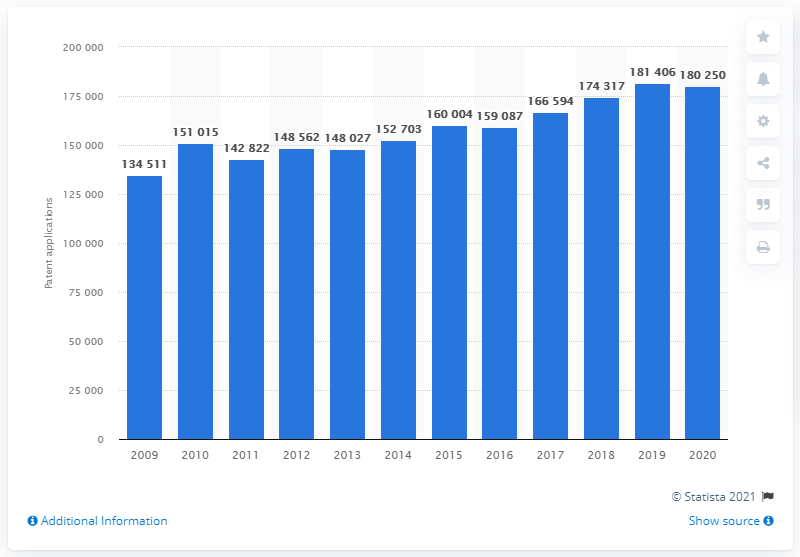Outline some significant characteristics in this image. In 2020, the number of patent applications in Europe was 180,250. In 2019, the number of patent applications in Europe was 174,317. 